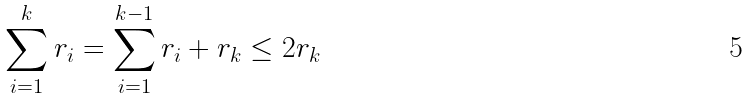<formula> <loc_0><loc_0><loc_500><loc_500>\sum _ { i = 1 } ^ { k } r _ { i } & = \sum _ { i = 1 } ^ { k - 1 } r _ { i } + r _ { k } \leq 2 r _ { k }</formula> 